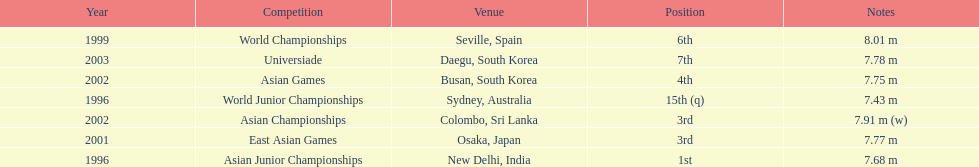What is the number of competitions that have been competed in? 7. 